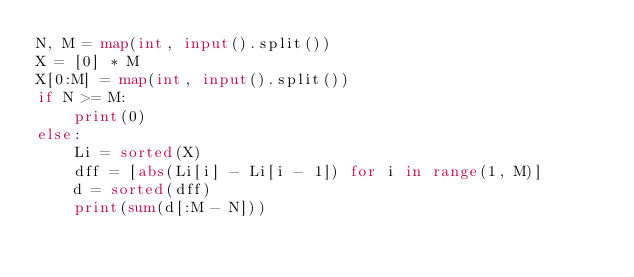Convert code to text. <code><loc_0><loc_0><loc_500><loc_500><_Python_>N, M = map(int, input().split())
X = [0] * M
X[0:M] = map(int, input().split())
if N >= M:
    print(0)
else:
    Li = sorted(X)
    dff = [abs(Li[i] - Li[i - 1]) for i in range(1, M)]
    d = sorted(dff)
    print(sum(d[:M - N]))</code> 